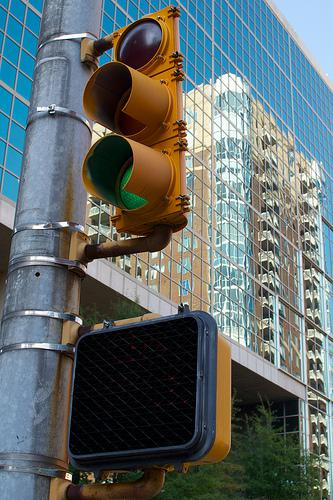Question: what color light is the traffic light?
Choices:
A. Yellow.
B. Red.
C. Orange.
D. Green.
Answer with the letter. Answer: D Question: how many lights does the traffic light have?
Choices:
A. Three.
B. One.
C. Two.
D. Four.
Answer with the letter. Answer: A Question: what color is the pole?
Choices:
A. Red.
B. Black.
C. Orange.
D. Grey.
Answer with the letter. Answer: D Question: what color is the traffic light case?
Choices:
A. Green.
B. Yellow.
C. Gray.
D. Black.
Answer with the letter. Answer: B Question: where was this photo taken?
Choices:
A. A street.
B. A bus.
C. A mall.
D. A house.
Answer with the letter. Answer: A 